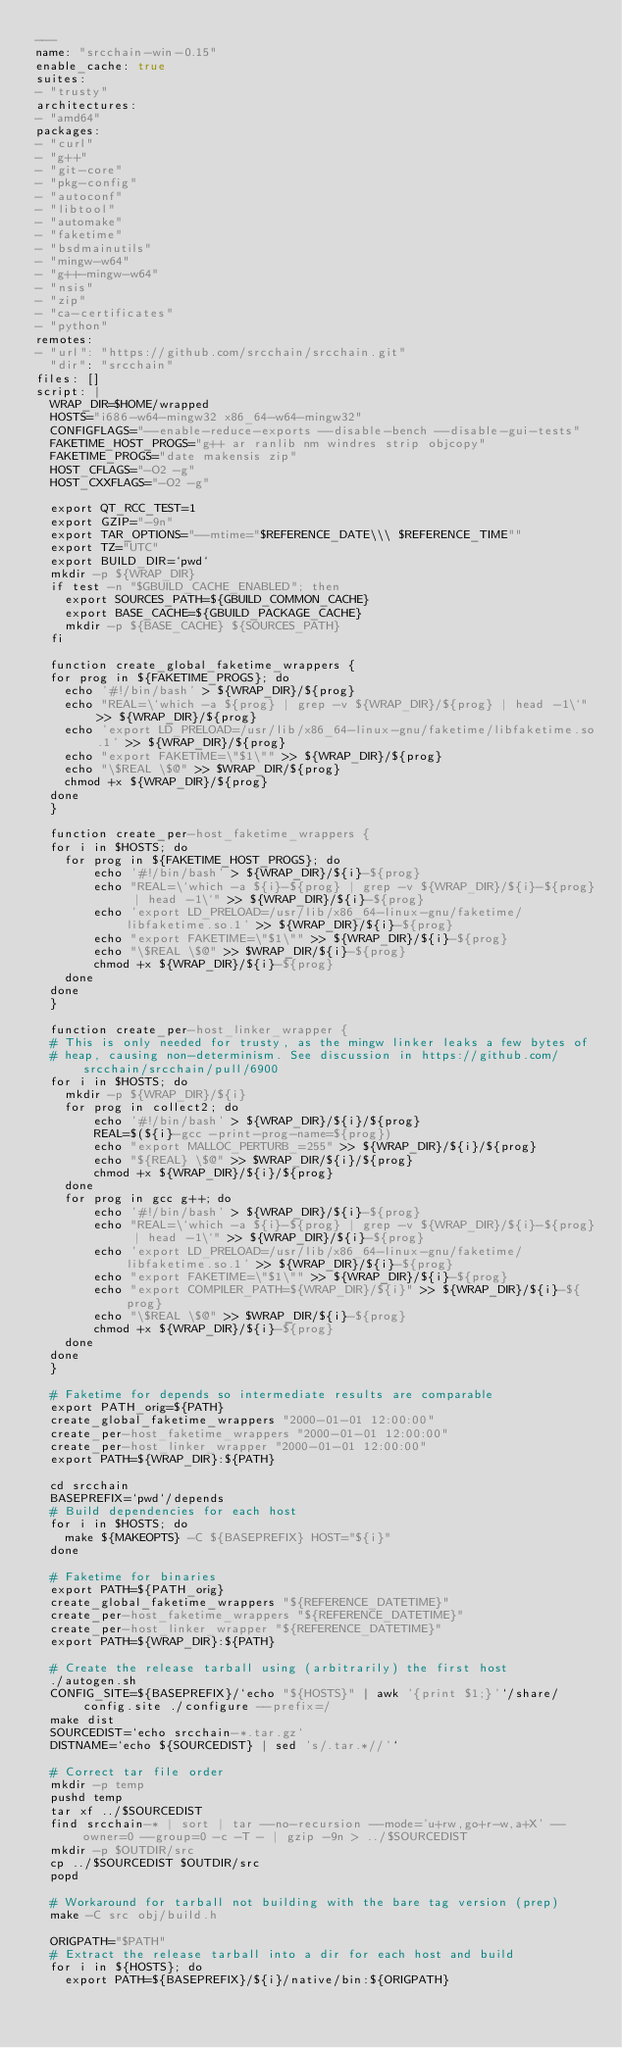Convert code to text. <code><loc_0><loc_0><loc_500><loc_500><_YAML_>---
name: "srcchain-win-0.15"
enable_cache: true
suites:
- "trusty"
architectures:
- "amd64"
packages:
- "curl"
- "g++"
- "git-core"
- "pkg-config"
- "autoconf"
- "libtool"
- "automake"
- "faketime"
- "bsdmainutils"
- "mingw-w64"
- "g++-mingw-w64"
- "nsis"
- "zip"
- "ca-certificates"
- "python"
remotes:
- "url": "https://github.com/srcchain/srcchain.git"
  "dir": "srcchain"
files: []
script: |
  WRAP_DIR=$HOME/wrapped
  HOSTS="i686-w64-mingw32 x86_64-w64-mingw32"
  CONFIGFLAGS="--enable-reduce-exports --disable-bench --disable-gui-tests"
  FAKETIME_HOST_PROGS="g++ ar ranlib nm windres strip objcopy"
  FAKETIME_PROGS="date makensis zip"
  HOST_CFLAGS="-O2 -g"
  HOST_CXXFLAGS="-O2 -g"

  export QT_RCC_TEST=1
  export GZIP="-9n"
  export TAR_OPTIONS="--mtime="$REFERENCE_DATE\\\ $REFERENCE_TIME""
  export TZ="UTC"
  export BUILD_DIR=`pwd`
  mkdir -p ${WRAP_DIR}
  if test -n "$GBUILD_CACHE_ENABLED"; then
    export SOURCES_PATH=${GBUILD_COMMON_CACHE}
    export BASE_CACHE=${GBUILD_PACKAGE_CACHE}
    mkdir -p ${BASE_CACHE} ${SOURCES_PATH}
  fi

  function create_global_faketime_wrappers {
  for prog in ${FAKETIME_PROGS}; do
    echo '#!/bin/bash' > ${WRAP_DIR}/${prog}
    echo "REAL=\`which -a ${prog} | grep -v ${WRAP_DIR}/${prog} | head -1\`" >> ${WRAP_DIR}/${prog}
    echo 'export LD_PRELOAD=/usr/lib/x86_64-linux-gnu/faketime/libfaketime.so.1' >> ${WRAP_DIR}/${prog}
    echo "export FAKETIME=\"$1\"" >> ${WRAP_DIR}/${prog}
    echo "\$REAL \$@" >> $WRAP_DIR/${prog}
    chmod +x ${WRAP_DIR}/${prog}
  done
  }

  function create_per-host_faketime_wrappers {
  for i in $HOSTS; do
    for prog in ${FAKETIME_HOST_PROGS}; do
        echo '#!/bin/bash' > ${WRAP_DIR}/${i}-${prog}
        echo "REAL=\`which -a ${i}-${prog} | grep -v ${WRAP_DIR}/${i}-${prog} | head -1\`" >> ${WRAP_DIR}/${i}-${prog}
        echo 'export LD_PRELOAD=/usr/lib/x86_64-linux-gnu/faketime/libfaketime.so.1' >> ${WRAP_DIR}/${i}-${prog}
        echo "export FAKETIME=\"$1\"" >> ${WRAP_DIR}/${i}-${prog}
        echo "\$REAL \$@" >> $WRAP_DIR/${i}-${prog}
        chmod +x ${WRAP_DIR}/${i}-${prog}
    done
  done
  }

  function create_per-host_linker_wrapper {
  # This is only needed for trusty, as the mingw linker leaks a few bytes of
  # heap, causing non-determinism. See discussion in https://github.com/srcchain/srcchain/pull/6900
  for i in $HOSTS; do
    mkdir -p ${WRAP_DIR}/${i}
    for prog in collect2; do
        echo '#!/bin/bash' > ${WRAP_DIR}/${i}/${prog}
        REAL=$(${i}-gcc -print-prog-name=${prog})
        echo "export MALLOC_PERTURB_=255" >> ${WRAP_DIR}/${i}/${prog}
        echo "${REAL} \$@" >> $WRAP_DIR/${i}/${prog}
        chmod +x ${WRAP_DIR}/${i}/${prog}
    done
    for prog in gcc g++; do
        echo '#!/bin/bash' > ${WRAP_DIR}/${i}-${prog}
        echo "REAL=\`which -a ${i}-${prog} | grep -v ${WRAP_DIR}/${i}-${prog} | head -1\`" >> ${WRAP_DIR}/${i}-${prog}
        echo 'export LD_PRELOAD=/usr/lib/x86_64-linux-gnu/faketime/libfaketime.so.1' >> ${WRAP_DIR}/${i}-${prog}
        echo "export FAKETIME=\"$1\"" >> ${WRAP_DIR}/${i}-${prog}
        echo "export COMPILER_PATH=${WRAP_DIR}/${i}" >> ${WRAP_DIR}/${i}-${prog}
        echo "\$REAL \$@" >> $WRAP_DIR/${i}-${prog}
        chmod +x ${WRAP_DIR}/${i}-${prog}
    done
  done
  }

  # Faketime for depends so intermediate results are comparable
  export PATH_orig=${PATH}
  create_global_faketime_wrappers "2000-01-01 12:00:00"
  create_per-host_faketime_wrappers "2000-01-01 12:00:00"
  create_per-host_linker_wrapper "2000-01-01 12:00:00"
  export PATH=${WRAP_DIR}:${PATH}

  cd srcchain
  BASEPREFIX=`pwd`/depends
  # Build dependencies for each host
  for i in $HOSTS; do
    make ${MAKEOPTS} -C ${BASEPREFIX} HOST="${i}"
  done

  # Faketime for binaries
  export PATH=${PATH_orig}
  create_global_faketime_wrappers "${REFERENCE_DATETIME}"
  create_per-host_faketime_wrappers "${REFERENCE_DATETIME}"
  create_per-host_linker_wrapper "${REFERENCE_DATETIME}"
  export PATH=${WRAP_DIR}:${PATH}

  # Create the release tarball using (arbitrarily) the first host
  ./autogen.sh
  CONFIG_SITE=${BASEPREFIX}/`echo "${HOSTS}" | awk '{print $1;}'`/share/config.site ./configure --prefix=/
  make dist
  SOURCEDIST=`echo srcchain-*.tar.gz`
  DISTNAME=`echo ${SOURCEDIST} | sed 's/.tar.*//'`

  # Correct tar file order
  mkdir -p temp
  pushd temp
  tar xf ../$SOURCEDIST
  find srcchain-* | sort | tar --no-recursion --mode='u+rw,go+r-w,a+X' --owner=0 --group=0 -c -T - | gzip -9n > ../$SOURCEDIST
  mkdir -p $OUTDIR/src
  cp ../$SOURCEDIST $OUTDIR/src
  popd

  # Workaround for tarball not building with the bare tag version (prep)
  make -C src obj/build.h

  ORIGPATH="$PATH"
  # Extract the release tarball into a dir for each host and build
  for i in ${HOSTS}; do
    export PATH=${BASEPREFIX}/${i}/native/bin:${ORIGPATH}</code> 